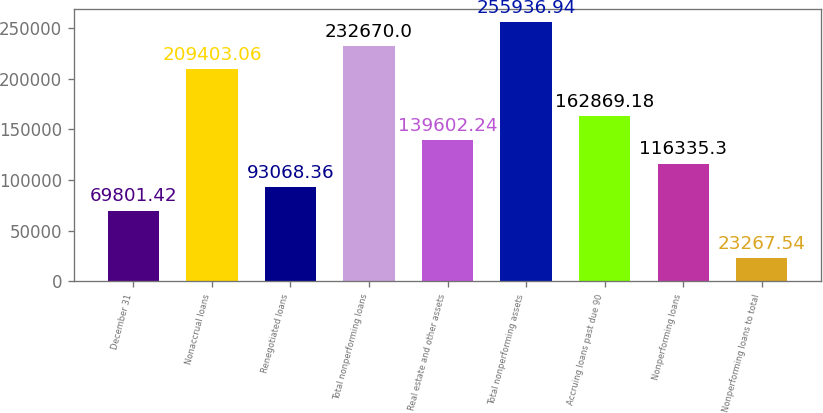<chart> <loc_0><loc_0><loc_500><loc_500><bar_chart><fcel>December 31<fcel>Nonaccrual loans<fcel>Renegotiated loans<fcel>Total nonperforming loans<fcel>Real estate and other assets<fcel>Total nonperforming assets<fcel>Accruing loans past due 90<fcel>Nonperforming loans<fcel>Nonperforming loans to total<nl><fcel>69801.4<fcel>209403<fcel>93068.4<fcel>232670<fcel>139602<fcel>255937<fcel>162869<fcel>116335<fcel>23267.5<nl></chart> 